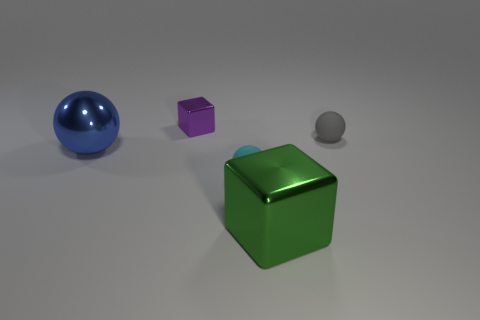There is a green shiny thing that is the same size as the blue sphere; what shape is it?
Offer a terse response. Cube. How many things are blocks that are in front of the cyan rubber thing or small gray things?
Give a very brief answer. 2. Does the large metal block have the same color as the tiny metallic cube?
Provide a succinct answer. No. There is a cube that is behind the big green block; how big is it?
Keep it short and to the point. Small. Is there a red metallic block that has the same size as the purple metallic cube?
Offer a terse response. No. Does the metal block in front of the purple object have the same size as the tiny shiny thing?
Provide a succinct answer. No. The purple metallic object has what size?
Keep it short and to the point. Small. There is a ball to the left of the block that is left of the matte thing left of the gray rubber ball; what color is it?
Keep it short and to the point. Blue. There is a large thing right of the tiny shiny block; is its color the same as the metal sphere?
Your answer should be compact. No. How many tiny objects are right of the tiny metallic cube and on the left side of the gray rubber object?
Your answer should be very brief. 1. 